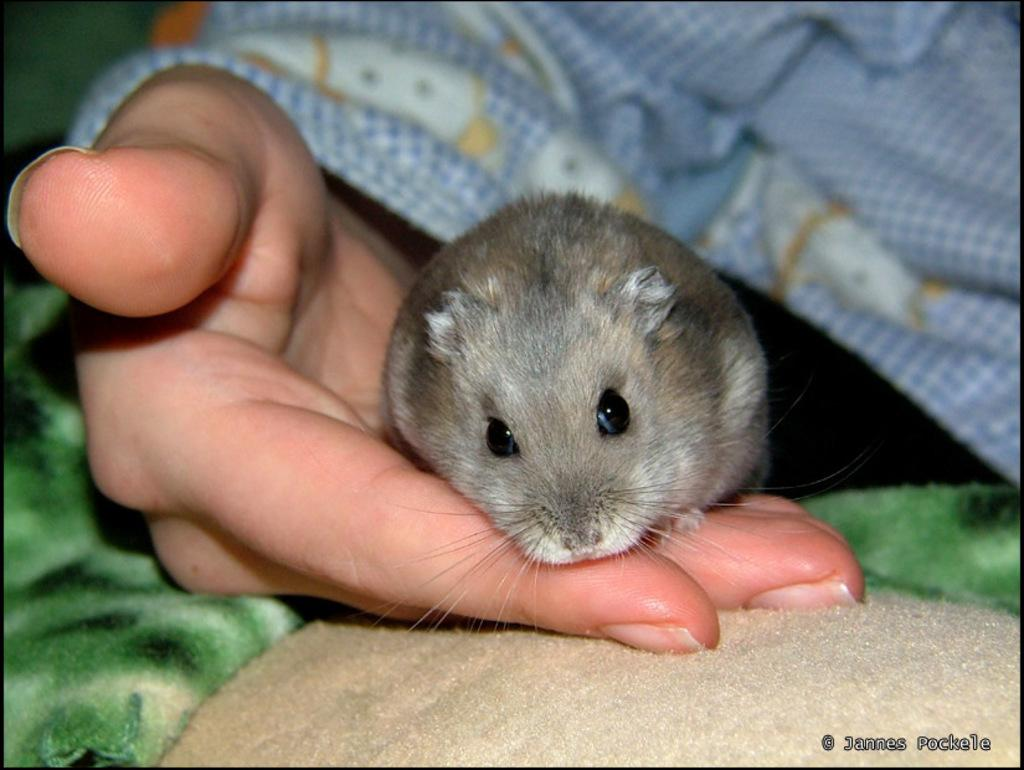What animal is present in the image? There is a mice in the image. Where is the mice located? The mice is on a person's hand. What type of material can be seen in the image? There is cloth visible in the image. Is there any text or logo present in the image? Yes, there is a watermark in the image. How would you describe the background of the image? The background of the image is blurry. What type of card can be seen with a tooth and wound in the image? There is no card, tooth, or wound present in the image. 